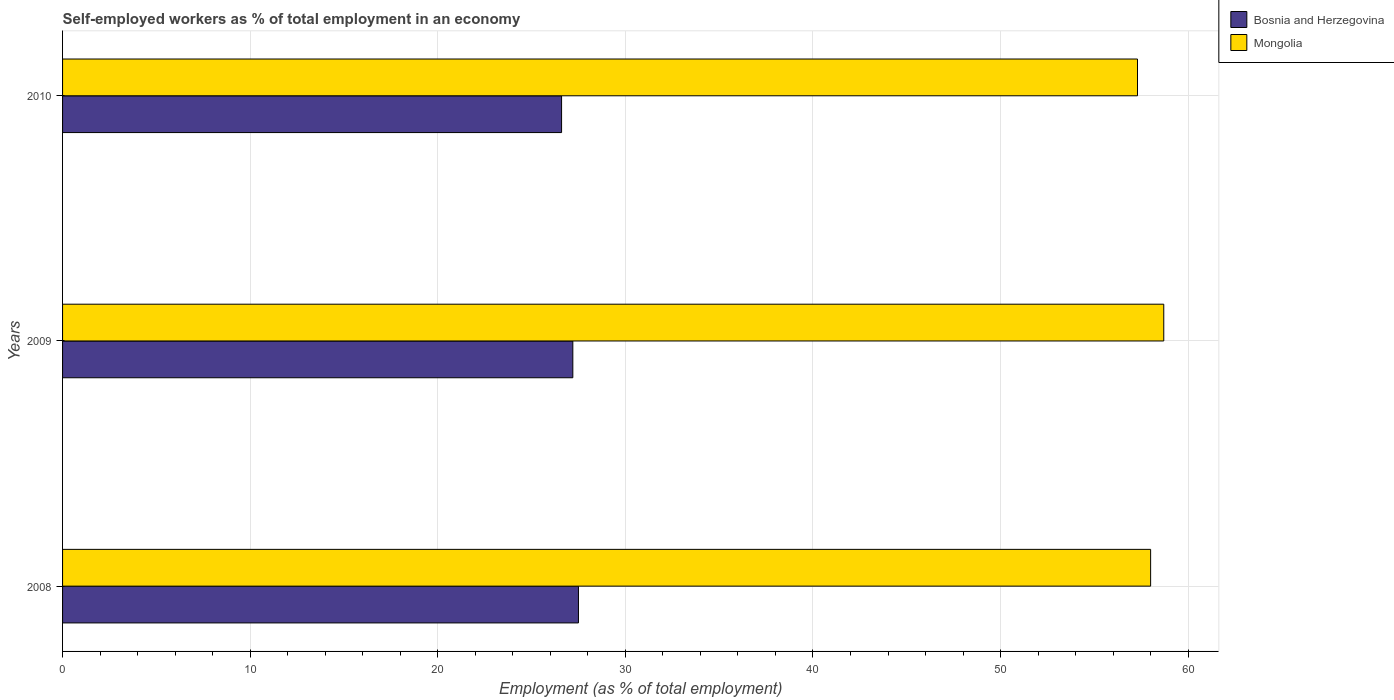How many different coloured bars are there?
Keep it short and to the point. 2. How many groups of bars are there?
Offer a terse response. 3. Are the number of bars per tick equal to the number of legend labels?
Offer a terse response. Yes. How many bars are there on the 2nd tick from the top?
Your response must be concise. 2. What is the label of the 1st group of bars from the top?
Make the answer very short. 2010. What is the percentage of self-employed workers in Mongolia in 2009?
Your response must be concise. 58.7. Across all years, what is the minimum percentage of self-employed workers in Mongolia?
Ensure brevity in your answer.  57.3. What is the total percentage of self-employed workers in Bosnia and Herzegovina in the graph?
Provide a short and direct response. 81.3. What is the difference between the percentage of self-employed workers in Bosnia and Herzegovina in 2008 and that in 2010?
Your response must be concise. 0.9. What is the difference between the percentage of self-employed workers in Mongolia in 2009 and the percentage of self-employed workers in Bosnia and Herzegovina in 2008?
Offer a terse response. 31.2. What is the average percentage of self-employed workers in Bosnia and Herzegovina per year?
Keep it short and to the point. 27.1. In the year 2010, what is the difference between the percentage of self-employed workers in Mongolia and percentage of self-employed workers in Bosnia and Herzegovina?
Your answer should be compact. 30.7. In how many years, is the percentage of self-employed workers in Bosnia and Herzegovina greater than 30 %?
Offer a terse response. 0. What is the ratio of the percentage of self-employed workers in Mongolia in 2009 to that in 2010?
Your answer should be compact. 1.02. Is the percentage of self-employed workers in Mongolia in 2008 less than that in 2010?
Provide a succinct answer. No. Is the difference between the percentage of self-employed workers in Mongolia in 2008 and 2009 greater than the difference between the percentage of self-employed workers in Bosnia and Herzegovina in 2008 and 2009?
Your answer should be very brief. No. What is the difference between the highest and the second highest percentage of self-employed workers in Mongolia?
Your answer should be compact. 0.7. What is the difference between the highest and the lowest percentage of self-employed workers in Bosnia and Herzegovina?
Offer a terse response. 0.9. Is the sum of the percentage of self-employed workers in Bosnia and Herzegovina in 2008 and 2010 greater than the maximum percentage of self-employed workers in Mongolia across all years?
Provide a short and direct response. No. What does the 2nd bar from the top in 2010 represents?
Ensure brevity in your answer.  Bosnia and Herzegovina. What does the 1st bar from the bottom in 2010 represents?
Provide a succinct answer. Bosnia and Herzegovina. How many bars are there?
Your answer should be very brief. 6. Are all the bars in the graph horizontal?
Your answer should be compact. Yes. Does the graph contain any zero values?
Your response must be concise. No. Where does the legend appear in the graph?
Give a very brief answer. Top right. What is the title of the graph?
Provide a short and direct response. Self-employed workers as % of total employment in an economy. Does "Monaco" appear as one of the legend labels in the graph?
Your answer should be compact. No. What is the label or title of the X-axis?
Make the answer very short. Employment (as % of total employment). What is the Employment (as % of total employment) of Mongolia in 2008?
Offer a terse response. 58. What is the Employment (as % of total employment) of Bosnia and Herzegovina in 2009?
Your answer should be compact. 27.2. What is the Employment (as % of total employment) in Mongolia in 2009?
Your response must be concise. 58.7. What is the Employment (as % of total employment) of Bosnia and Herzegovina in 2010?
Ensure brevity in your answer.  26.6. What is the Employment (as % of total employment) in Mongolia in 2010?
Make the answer very short. 57.3. Across all years, what is the maximum Employment (as % of total employment) in Mongolia?
Ensure brevity in your answer.  58.7. Across all years, what is the minimum Employment (as % of total employment) of Bosnia and Herzegovina?
Your answer should be compact. 26.6. Across all years, what is the minimum Employment (as % of total employment) of Mongolia?
Your answer should be compact. 57.3. What is the total Employment (as % of total employment) of Bosnia and Herzegovina in the graph?
Provide a short and direct response. 81.3. What is the total Employment (as % of total employment) in Mongolia in the graph?
Give a very brief answer. 174. What is the difference between the Employment (as % of total employment) in Bosnia and Herzegovina in 2008 and that in 2009?
Give a very brief answer. 0.3. What is the difference between the Employment (as % of total employment) of Bosnia and Herzegovina in 2008 and that in 2010?
Keep it short and to the point. 0.9. What is the difference between the Employment (as % of total employment) in Mongolia in 2008 and that in 2010?
Ensure brevity in your answer.  0.7. What is the difference between the Employment (as % of total employment) of Bosnia and Herzegovina in 2009 and that in 2010?
Offer a terse response. 0.6. What is the difference between the Employment (as % of total employment) of Mongolia in 2009 and that in 2010?
Keep it short and to the point. 1.4. What is the difference between the Employment (as % of total employment) of Bosnia and Herzegovina in 2008 and the Employment (as % of total employment) of Mongolia in 2009?
Ensure brevity in your answer.  -31.2. What is the difference between the Employment (as % of total employment) in Bosnia and Herzegovina in 2008 and the Employment (as % of total employment) in Mongolia in 2010?
Your answer should be very brief. -29.8. What is the difference between the Employment (as % of total employment) of Bosnia and Herzegovina in 2009 and the Employment (as % of total employment) of Mongolia in 2010?
Your answer should be compact. -30.1. What is the average Employment (as % of total employment) in Bosnia and Herzegovina per year?
Your answer should be compact. 27.1. In the year 2008, what is the difference between the Employment (as % of total employment) in Bosnia and Herzegovina and Employment (as % of total employment) in Mongolia?
Keep it short and to the point. -30.5. In the year 2009, what is the difference between the Employment (as % of total employment) of Bosnia and Herzegovina and Employment (as % of total employment) of Mongolia?
Give a very brief answer. -31.5. In the year 2010, what is the difference between the Employment (as % of total employment) of Bosnia and Herzegovina and Employment (as % of total employment) of Mongolia?
Give a very brief answer. -30.7. What is the ratio of the Employment (as % of total employment) in Mongolia in 2008 to that in 2009?
Offer a very short reply. 0.99. What is the ratio of the Employment (as % of total employment) in Bosnia and Herzegovina in 2008 to that in 2010?
Offer a terse response. 1.03. What is the ratio of the Employment (as % of total employment) in Mongolia in 2008 to that in 2010?
Your response must be concise. 1.01. What is the ratio of the Employment (as % of total employment) in Bosnia and Herzegovina in 2009 to that in 2010?
Provide a succinct answer. 1.02. What is the ratio of the Employment (as % of total employment) of Mongolia in 2009 to that in 2010?
Your response must be concise. 1.02. What is the difference between the highest and the second highest Employment (as % of total employment) in Bosnia and Herzegovina?
Offer a terse response. 0.3. What is the difference between the highest and the lowest Employment (as % of total employment) of Bosnia and Herzegovina?
Your answer should be compact. 0.9. What is the difference between the highest and the lowest Employment (as % of total employment) of Mongolia?
Ensure brevity in your answer.  1.4. 